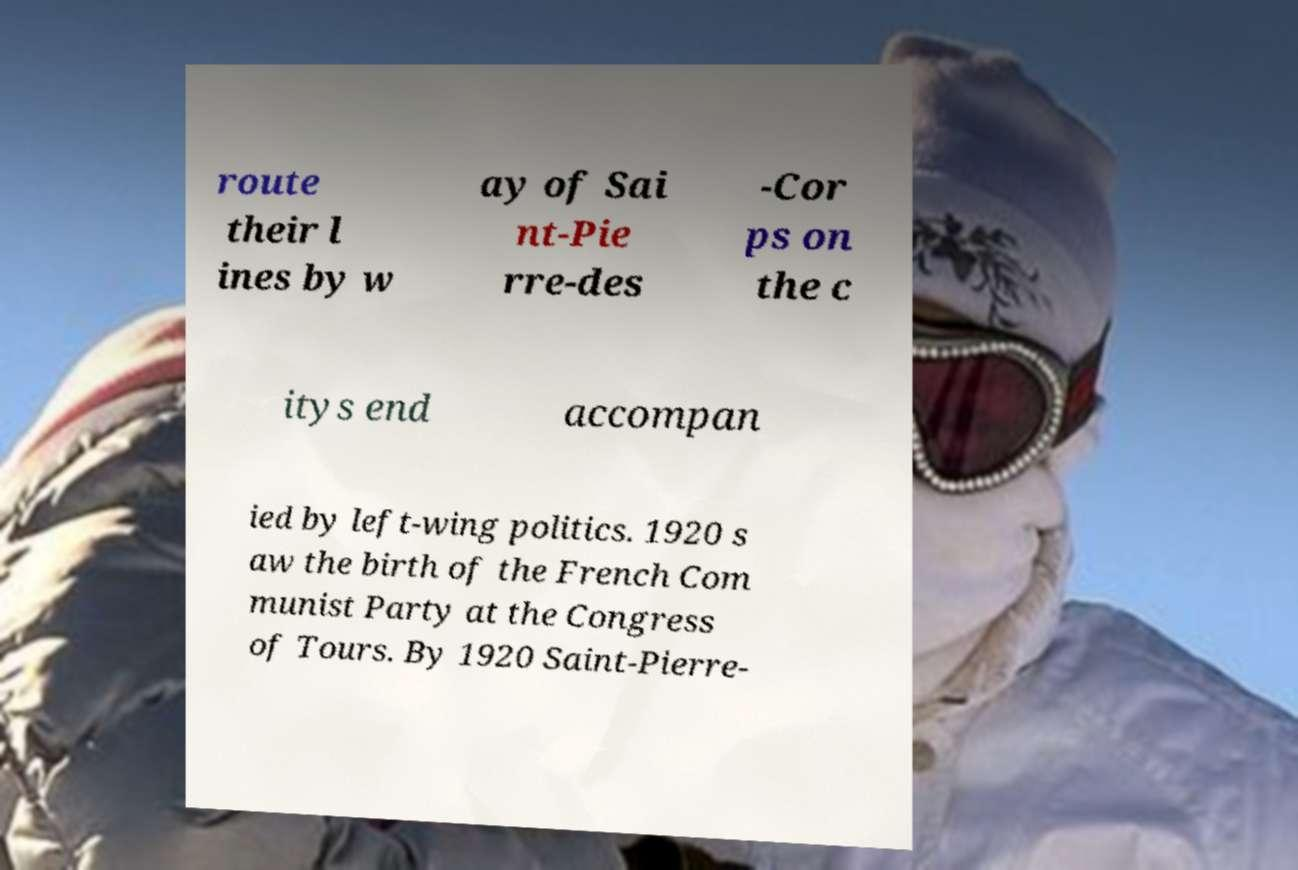Could you assist in decoding the text presented in this image and type it out clearly? route their l ines by w ay of Sai nt-Pie rre-des -Cor ps on the c itys end accompan ied by left-wing politics. 1920 s aw the birth of the French Com munist Party at the Congress of Tours. By 1920 Saint-Pierre- 